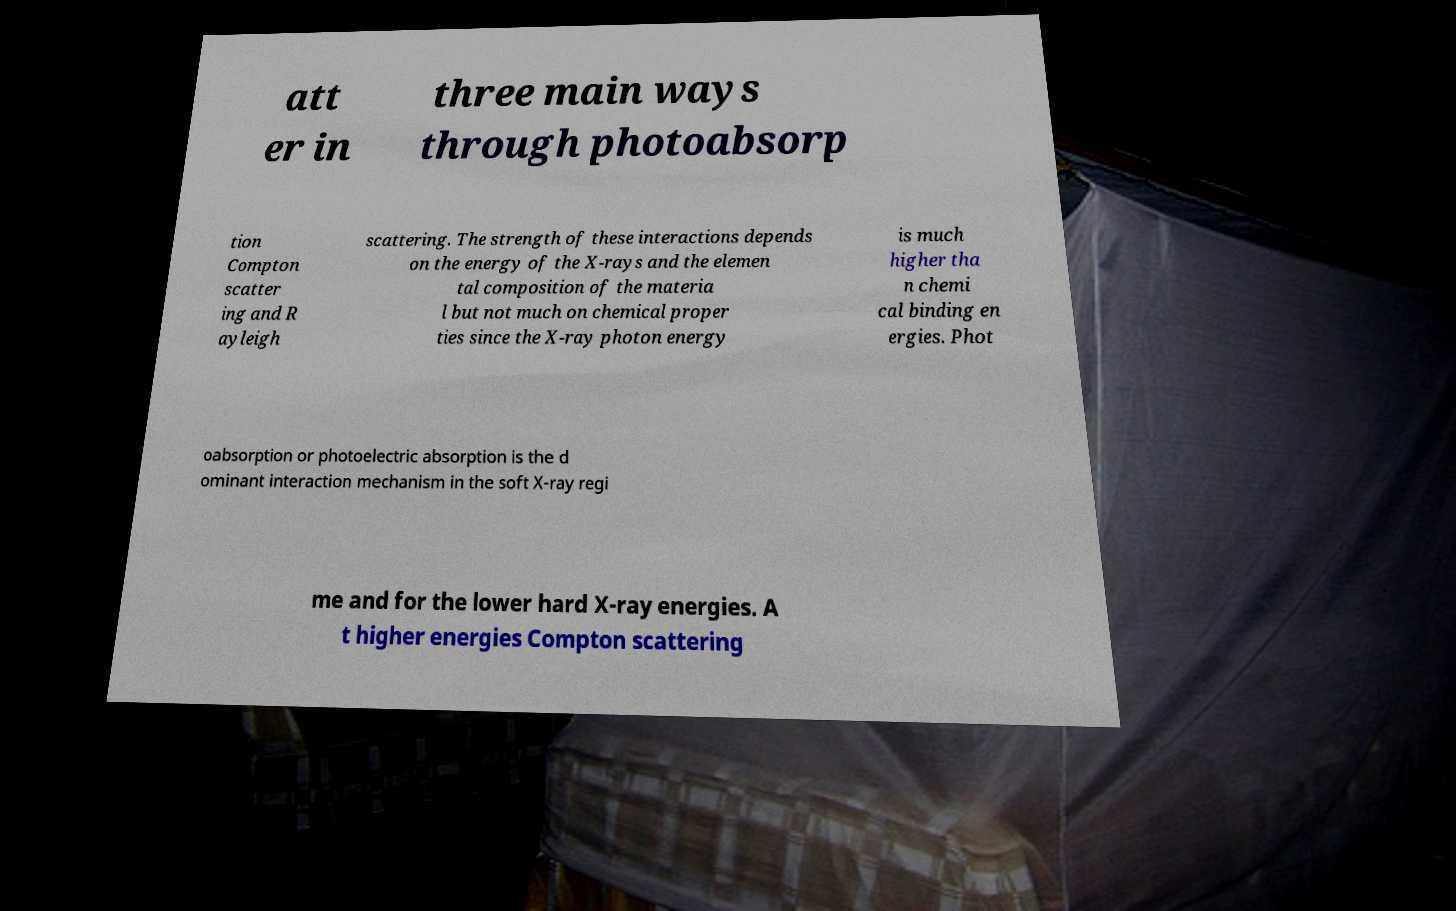Can you read and provide the text displayed in the image?This photo seems to have some interesting text. Can you extract and type it out for me? att er in three main ways through photoabsorp tion Compton scatter ing and R ayleigh scattering. The strength of these interactions depends on the energy of the X-rays and the elemen tal composition of the materia l but not much on chemical proper ties since the X-ray photon energy is much higher tha n chemi cal binding en ergies. Phot oabsorption or photoelectric absorption is the d ominant interaction mechanism in the soft X-ray regi me and for the lower hard X-ray energies. A t higher energies Compton scattering 